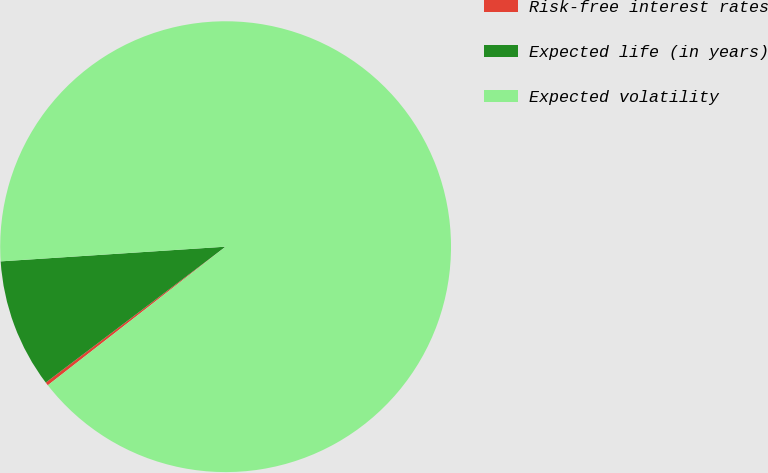<chart> <loc_0><loc_0><loc_500><loc_500><pie_chart><fcel>Risk-free interest rates<fcel>Expected life (in years)<fcel>Expected volatility<nl><fcel>0.24%<fcel>9.26%<fcel>90.5%<nl></chart> 